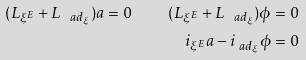<formula> <loc_0><loc_0><loc_500><loc_500>( L _ { \xi ^ { E } } + L _ { \ a d _ { \xi } } ) a = 0 \quad ( L _ { \xi ^ { E } } + L _ { \ a d _ { \xi } } ) \phi = 0 \\ i _ { \xi ^ { E } } a - i _ { \ a d _ { \xi } } \phi = 0</formula> 